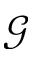Convert formula to latex. <formula><loc_0><loc_0><loc_500><loc_500>\mathcal { G }</formula> 